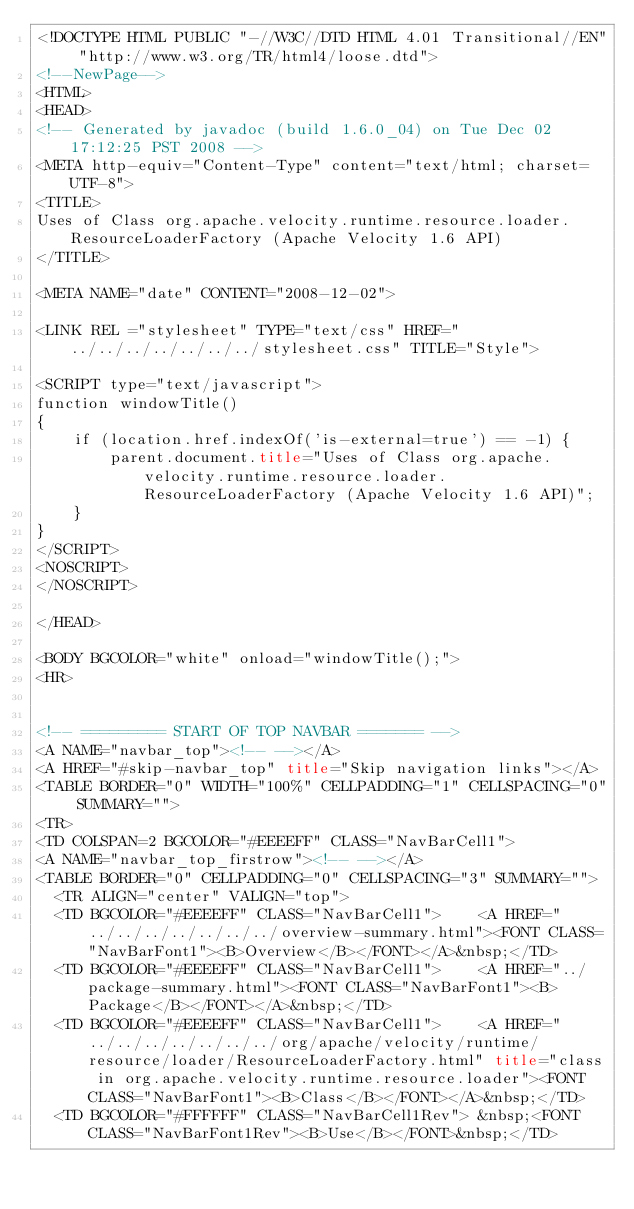Convert code to text. <code><loc_0><loc_0><loc_500><loc_500><_HTML_><!DOCTYPE HTML PUBLIC "-//W3C//DTD HTML 4.01 Transitional//EN" "http://www.w3.org/TR/html4/loose.dtd">
<!--NewPage-->
<HTML>
<HEAD>
<!-- Generated by javadoc (build 1.6.0_04) on Tue Dec 02 17:12:25 PST 2008 -->
<META http-equiv="Content-Type" content="text/html; charset=UTF-8">
<TITLE>
Uses of Class org.apache.velocity.runtime.resource.loader.ResourceLoaderFactory (Apache Velocity 1.6 API)
</TITLE>

<META NAME="date" CONTENT="2008-12-02">

<LINK REL ="stylesheet" TYPE="text/css" HREF="../../../../../../../stylesheet.css" TITLE="Style">

<SCRIPT type="text/javascript">
function windowTitle()
{
    if (location.href.indexOf('is-external=true') == -1) {
        parent.document.title="Uses of Class org.apache.velocity.runtime.resource.loader.ResourceLoaderFactory (Apache Velocity 1.6 API)";
    }
}
</SCRIPT>
<NOSCRIPT>
</NOSCRIPT>

</HEAD>

<BODY BGCOLOR="white" onload="windowTitle();">
<HR>


<!-- ========= START OF TOP NAVBAR ======= -->
<A NAME="navbar_top"><!-- --></A>
<A HREF="#skip-navbar_top" title="Skip navigation links"></A>
<TABLE BORDER="0" WIDTH="100%" CELLPADDING="1" CELLSPACING="0" SUMMARY="">
<TR>
<TD COLSPAN=2 BGCOLOR="#EEEEFF" CLASS="NavBarCell1">
<A NAME="navbar_top_firstrow"><!-- --></A>
<TABLE BORDER="0" CELLPADDING="0" CELLSPACING="3" SUMMARY="">
  <TR ALIGN="center" VALIGN="top">
  <TD BGCOLOR="#EEEEFF" CLASS="NavBarCell1">    <A HREF="../../../../../../../overview-summary.html"><FONT CLASS="NavBarFont1"><B>Overview</B></FONT></A>&nbsp;</TD>
  <TD BGCOLOR="#EEEEFF" CLASS="NavBarCell1">    <A HREF="../package-summary.html"><FONT CLASS="NavBarFont1"><B>Package</B></FONT></A>&nbsp;</TD>
  <TD BGCOLOR="#EEEEFF" CLASS="NavBarCell1">    <A HREF="../../../../../../../org/apache/velocity/runtime/resource/loader/ResourceLoaderFactory.html" title="class in org.apache.velocity.runtime.resource.loader"><FONT CLASS="NavBarFont1"><B>Class</B></FONT></A>&nbsp;</TD>
  <TD BGCOLOR="#FFFFFF" CLASS="NavBarCell1Rev"> &nbsp;<FONT CLASS="NavBarFont1Rev"><B>Use</B></FONT>&nbsp;</TD></code> 